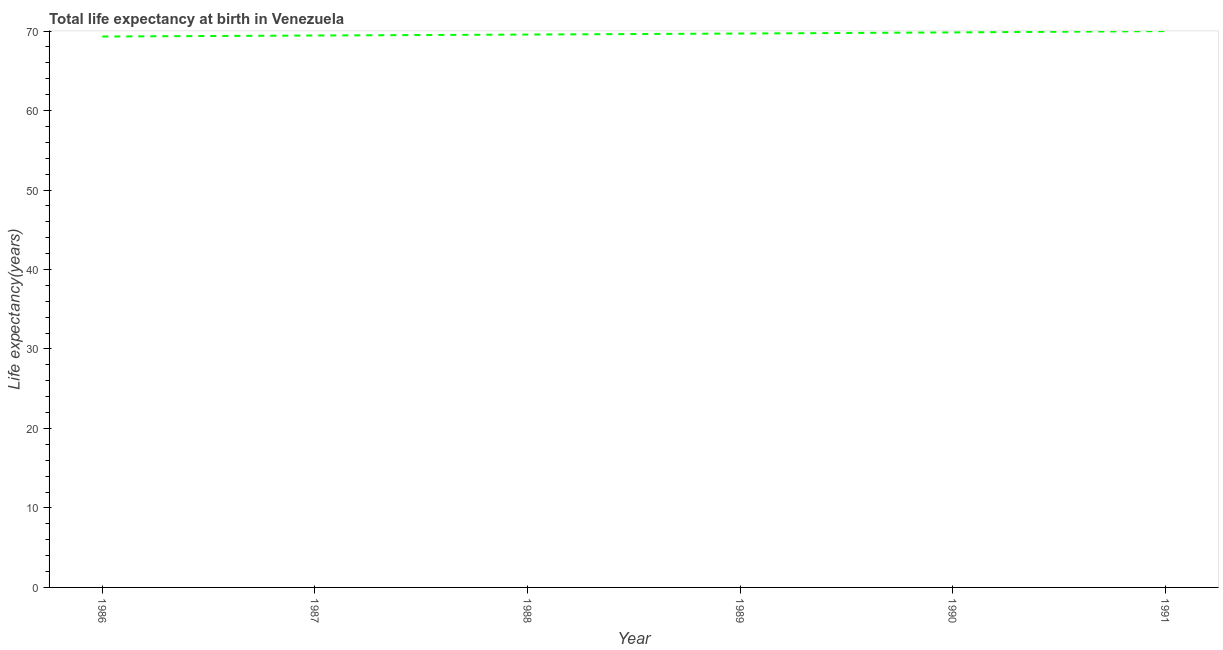What is the life expectancy at birth in 1987?
Keep it short and to the point. 69.44. Across all years, what is the maximum life expectancy at birth?
Provide a succinct answer. 69.99. Across all years, what is the minimum life expectancy at birth?
Give a very brief answer. 69.31. In which year was the life expectancy at birth minimum?
Provide a short and direct response. 1986. What is the sum of the life expectancy at birth?
Make the answer very short. 417.82. What is the difference between the life expectancy at birth in 1987 and 1989?
Your response must be concise. -0.25. What is the average life expectancy at birth per year?
Keep it short and to the point. 69.64. What is the median life expectancy at birth?
Offer a very short reply. 69.62. In how many years, is the life expectancy at birth greater than 28 years?
Keep it short and to the point. 6. Do a majority of the years between 1990 and 1988 (inclusive) have life expectancy at birth greater than 48 years?
Offer a very short reply. No. What is the ratio of the life expectancy at birth in 1988 to that in 1989?
Keep it short and to the point. 1. What is the difference between the highest and the second highest life expectancy at birth?
Make the answer very short. 0.17. Is the sum of the life expectancy at birth in 1988 and 1991 greater than the maximum life expectancy at birth across all years?
Make the answer very short. Yes. What is the difference between the highest and the lowest life expectancy at birth?
Give a very brief answer. 0.68. Does the life expectancy at birth monotonically increase over the years?
Offer a very short reply. Yes. How many years are there in the graph?
Offer a very short reply. 6. What is the difference between two consecutive major ticks on the Y-axis?
Keep it short and to the point. 10. Does the graph contain any zero values?
Give a very brief answer. No. What is the title of the graph?
Offer a terse response. Total life expectancy at birth in Venezuela. What is the label or title of the X-axis?
Offer a very short reply. Year. What is the label or title of the Y-axis?
Your answer should be compact. Life expectancy(years). What is the Life expectancy(years) in 1986?
Your answer should be compact. 69.31. What is the Life expectancy(years) of 1987?
Your answer should be compact. 69.44. What is the Life expectancy(years) of 1988?
Offer a very short reply. 69.56. What is the Life expectancy(years) of 1989?
Provide a succinct answer. 69.69. What is the Life expectancy(years) in 1990?
Keep it short and to the point. 69.83. What is the Life expectancy(years) in 1991?
Make the answer very short. 69.99. What is the difference between the Life expectancy(years) in 1986 and 1987?
Keep it short and to the point. -0.13. What is the difference between the Life expectancy(years) in 1986 and 1988?
Offer a terse response. -0.25. What is the difference between the Life expectancy(years) in 1986 and 1989?
Your response must be concise. -0.38. What is the difference between the Life expectancy(years) in 1986 and 1990?
Keep it short and to the point. -0.52. What is the difference between the Life expectancy(years) in 1986 and 1991?
Make the answer very short. -0.68. What is the difference between the Life expectancy(years) in 1987 and 1988?
Your answer should be compact. -0.12. What is the difference between the Life expectancy(years) in 1987 and 1989?
Offer a very short reply. -0.25. What is the difference between the Life expectancy(years) in 1987 and 1990?
Offer a terse response. -0.39. What is the difference between the Life expectancy(years) in 1987 and 1991?
Your answer should be compact. -0.56. What is the difference between the Life expectancy(years) in 1988 and 1989?
Your answer should be very brief. -0.13. What is the difference between the Life expectancy(years) in 1988 and 1990?
Offer a very short reply. -0.27. What is the difference between the Life expectancy(years) in 1988 and 1991?
Give a very brief answer. -0.43. What is the difference between the Life expectancy(years) in 1989 and 1990?
Provide a short and direct response. -0.14. What is the difference between the Life expectancy(years) in 1989 and 1991?
Provide a succinct answer. -0.31. What is the difference between the Life expectancy(years) in 1990 and 1991?
Provide a succinct answer. -0.17. What is the ratio of the Life expectancy(years) in 1986 to that in 1987?
Provide a succinct answer. 1. What is the ratio of the Life expectancy(years) in 1986 to that in 1989?
Keep it short and to the point. 0.99. What is the ratio of the Life expectancy(years) in 1986 to that in 1990?
Your answer should be compact. 0.99. What is the ratio of the Life expectancy(years) in 1987 to that in 1988?
Keep it short and to the point. 1. What is the ratio of the Life expectancy(years) in 1987 to that in 1989?
Make the answer very short. 1. What is the ratio of the Life expectancy(years) in 1987 to that in 1990?
Give a very brief answer. 0.99. What is the ratio of the Life expectancy(years) in 1988 to that in 1989?
Provide a succinct answer. 1. What is the ratio of the Life expectancy(years) in 1988 to that in 1991?
Provide a short and direct response. 0.99. What is the ratio of the Life expectancy(years) in 1989 to that in 1991?
Your answer should be very brief. 1. What is the ratio of the Life expectancy(years) in 1990 to that in 1991?
Provide a succinct answer. 1. 